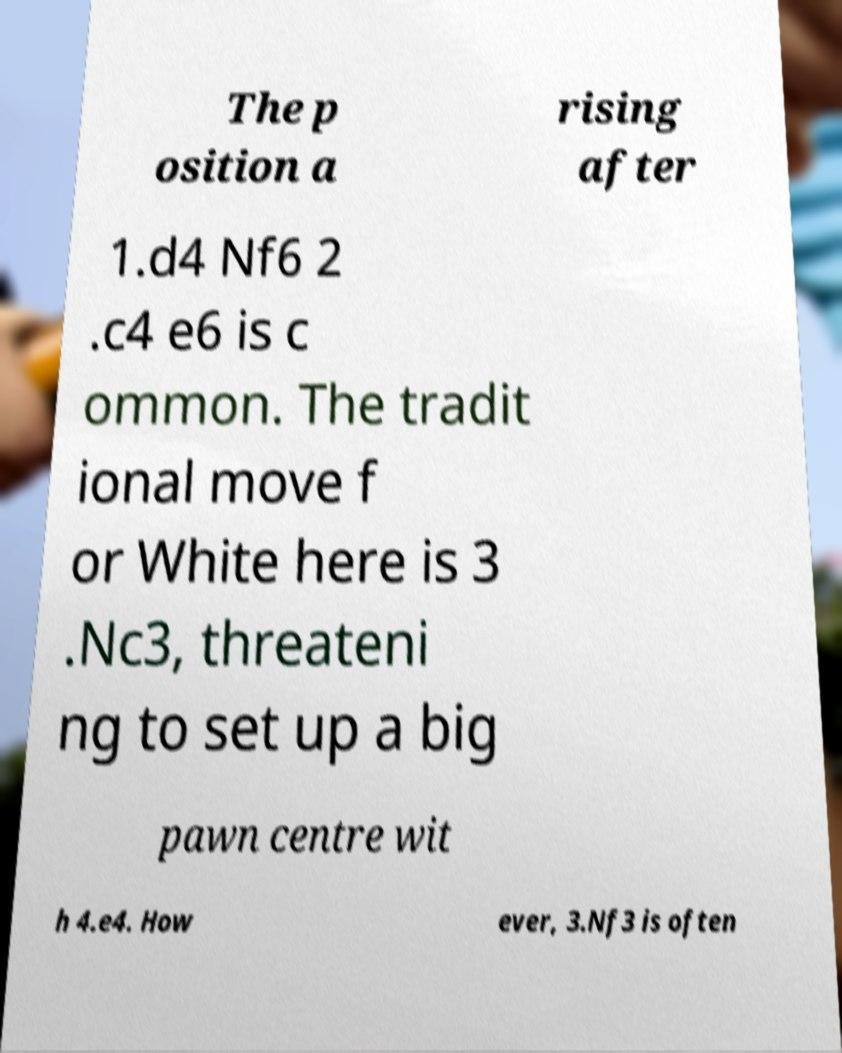Could you assist in decoding the text presented in this image and type it out clearly? The p osition a rising after 1.d4 Nf6 2 .c4 e6 is c ommon. The tradit ional move f or White here is 3 .Nc3, threateni ng to set up a big pawn centre wit h 4.e4. How ever, 3.Nf3 is often 